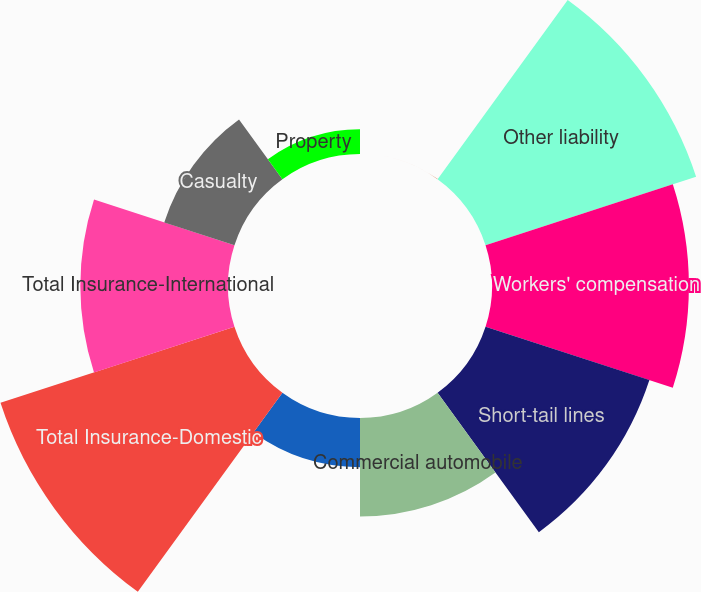<chart> <loc_0><loc_0><loc_500><loc_500><pie_chart><fcel>(In thousands)<fcel>Other liability<fcel>Workers' compensation<fcel>Short-tail lines<fcel>Commercial automobile<fcel>Professional liability<fcel>Total Insurance-Domestic<fcel>Total Insurance-International<fcel>Casualty<fcel>Property<nl><fcel>0.01%<fcel>17.99%<fcel>16.0%<fcel>14.0%<fcel>8.0%<fcel>4.0%<fcel>19.99%<fcel>12.0%<fcel>6.0%<fcel>2.01%<nl></chart> 